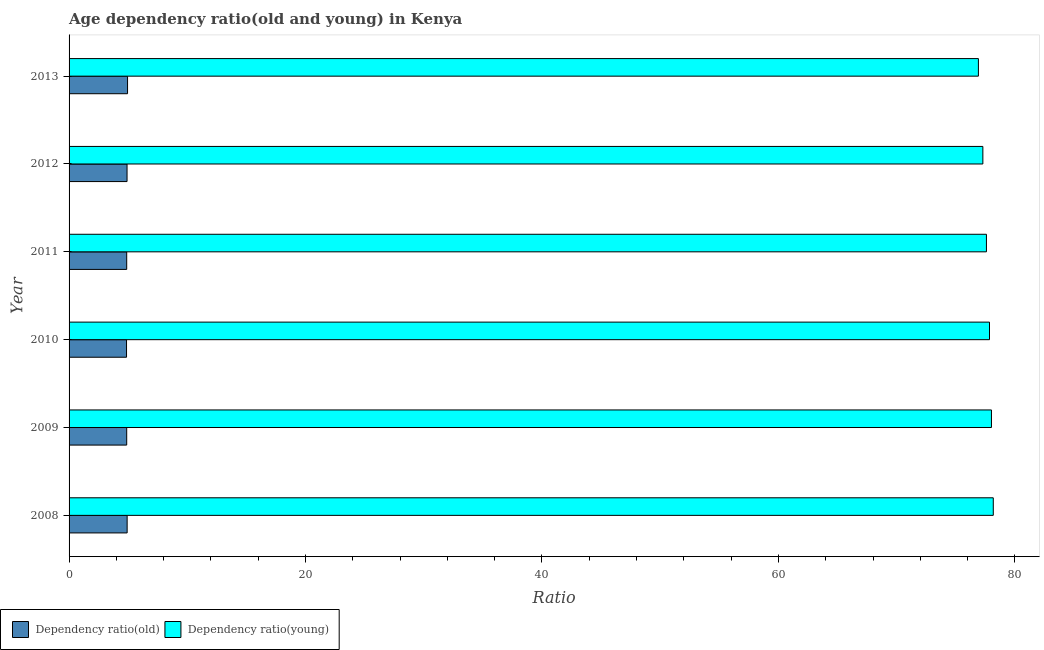How many different coloured bars are there?
Provide a succinct answer. 2. Are the number of bars on each tick of the Y-axis equal?
Offer a very short reply. Yes. In how many cases, is the number of bars for a given year not equal to the number of legend labels?
Provide a succinct answer. 0. What is the age dependency ratio(young) in 2009?
Give a very brief answer. 78.02. Across all years, what is the maximum age dependency ratio(old)?
Offer a very short reply. 4.95. Across all years, what is the minimum age dependency ratio(young)?
Provide a succinct answer. 76.92. In which year was the age dependency ratio(old) maximum?
Offer a terse response. 2013. In which year was the age dependency ratio(young) minimum?
Keep it short and to the point. 2013. What is the total age dependency ratio(old) in the graph?
Offer a terse response. 29.37. What is the difference between the age dependency ratio(old) in 2012 and that in 2013?
Your answer should be compact. -0.04. What is the difference between the age dependency ratio(old) in 2013 and the age dependency ratio(young) in 2011?
Provide a short and direct response. -72.65. What is the average age dependency ratio(old) per year?
Ensure brevity in your answer.  4.89. In the year 2009, what is the difference between the age dependency ratio(old) and age dependency ratio(young)?
Make the answer very short. -73.14. What is the difference between the highest and the second highest age dependency ratio(young)?
Your answer should be very brief. 0.15. What is the difference between the highest and the lowest age dependency ratio(young)?
Provide a short and direct response. 1.26. In how many years, is the age dependency ratio(young) greater than the average age dependency ratio(young) taken over all years?
Give a very brief answer. 3. What does the 2nd bar from the top in 2010 represents?
Provide a succinct answer. Dependency ratio(old). What does the 1st bar from the bottom in 2012 represents?
Provide a succinct answer. Dependency ratio(old). How many bars are there?
Offer a terse response. 12. What is the difference between two consecutive major ticks on the X-axis?
Offer a very short reply. 20. Does the graph contain any zero values?
Keep it short and to the point. No. Where does the legend appear in the graph?
Your answer should be very brief. Bottom left. What is the title of the graph?
Your answer should be compact. Age dependency ratio(old and young) in Kenya. Does "Time to import" appear as one of the legend labels in the graph?
Make the answer very short. No. What is the label or title of the X-axis?
Give a very brief answer. Ratio. What is the label or title of the Y-axis?
Keep it short and to the point. Year. What is the Ratio of Dependency ratio(old) in 2008?
Offer a terse response. 4.91. What is the Ratio in Dependency ratio(young) in 2008?
Provide a succinct answer. 78.17. What is the Ratio in Dependency ratio(old) in 2009?
Offer a very short reply. 4.87. What is the Ratio of Dependency ratio(young) in 2009?
Make the answer very short. 78.02. What is the Ratio in Dependency ratio(old) in 2010?
Keep it short and to the point. 4.86. What is the Ratio of Dependency ratio(young) in 2010?
Your answer should be compact. 77.85. What is the Ratio in Dependency ratio(old) in 2011?
Your response must be concise. 4.87. What is the Ratio in Dependency ratio(young) in 2011?
Provide a succinct answer. 77.6. What is the Ratio in Dependency ratio(old) in 2012?
Provide a short and direct response. 4.9. What is the Ratio in Dependency ratio(young) in 2012?
Offer a very short reply. 77.29. What is the Ratio in Dependency ratio(old) in 2013?
Your answer should be very brief. 4.95. What is the Ratio in Dependency ratio(young) in 2013?
Keep it short and to the point. 76.92. Across all years, what is the maximum Ratio of Dependency ratio(old)?
Provide a succinct answer. 4.95. Across all years, what is the maximum Ratio of Dependency ratio(young)?
Your answer should be compact. 78.17. Across all years, what is the minimum Ratio in Dependency ratio(old)?
Keep it short and to the point. 4.86. Across all years, what is the minimum Ratio of Dependency ratio(young)?
Keep it short and to the point. 76.92. What is the total Ratio of Dependency ratio(old) in the graph?
Provide a short and direct response. 29.37. What is the total Ratio in Dependency ratio(young) in the graph?
Your response must be concise. 465.85. What is the difference between the Ratio of Dependency ratio(old) in 2008 and that in 2009?
Give a very brief answer. 0.04. What is the difference between the Ratio of Dependency ratio(young) in 2008 and that in 2009?
Your answer should be compact. 0.16. What is the difference between the Ratio of Dependency ratio(old) in 2008 and that in 2010?
Your answer should be compact. 0.05. What is the difference between the Ratio of Dependency ratio(young) in 2008 and that in 2010?
Provide a short and direct response. 0.32. What is the difference between the Ratio of Dependency ratio(old) in 2008 and that in 2011?
Offer a terse response. 0.04. What is the difference between the Ratio in Dependency ratio(young) in 2008 and that in 2011?
Your answer should be very brief. 0.58. What is the difference between the Ratio of Dependency ratio(old) in 2008 and that in 2012?
Provide a short and direct response. 0.01. What is the difference between the Ratio in Dependency ratio(young) in 2008 and that in 2012?
Give a very brief answer. 0.88. What is the difference between the Ratio in Dependency ratio(old) in 2008 and that in 2013?
Your response must be concise. -0.03. What is the difference between the Ratio of Dependency ratio(young) in 2008 and that in 2013?
Offer a terse response. 1.26. What is the difference between the Ratio in Dependency ratio(old) in 2009 and that in 2010?
Provide a succinct answer. 0.01. What is the difference between the Ratio of Dependency ratio(young) in 2009 and that in 2010?
Offer a very short reply. 0.17. What is the difference between the Ratio of Dependency ratio(old) in 2009 and that in 2011?
Your answer should be very brief. -0. What is the difference between the Ratio of Dependency ratio(young) in 2009 and that in 2011?
Ensure brevity in your answer.  0.42. What is the difference between the Ratio in Dependency ratio(old) in 2009 and that in 2012?
Provide a succinct answer. -0.03. What is the difference between the Ratio in Dependency ratio(young) in 2009 and that in 2012?
Give a very brief answer. 0.73. What is the difference between the Ratio of Dependency ratio(old) in 2009 and that in 2013?
Your answer should be compact. -0.07. What is the difference between the Ratio of Dependency ratio(young) in 2009 and that in 2013?
Offer a terse response. 1.1. What is the difference between the Ratio in Dependency ratio(old) in 2010 and that in 2011?
Provide a succinct answer. -0.01. What is the difference between the Ratio in Dependency ratio(young) in 2010 and that in 2011?
Your answer should be compact. 0.26. What is the difference between the Ratio of Dependency ratio(old) in 2010 and that in 2012?
Your answer should be very brief. -0.04. What is the difference between the Ratio in Dependency ratio(young) in 2010 and that in 2012?
Your response must be concise. 0.56. What is the difference between the Ratio of Dependency ratio(old) in 2010 and that in 2013?
Make the answer very short. -0.09. What is the difference between the Ratio of Dependency ratio(young) in 2010 and that in 2013?
Keep it short and to the point. 0.94. What is the difference between the Ratio in Dependency ratio(old) in 2011 and that in 2012?
Make the answer very short. -0.03. What is the difference between the Ratio in Dependency ratio(young) in 2011 and that in 2012?
Offer a very short reply. 0.3. What is the difference between the Ratio in Dependency ratio(old) in 2011 and that in 2013?
Provide a short and direct response. -0.07. What is the difference between the Ratio of Dependency ratio(young) in 2011 and that in 2013?
Offer a very short reply. 0.68. What is the difference between the Ratio of Dependency ratio(old) in 2012 and that in 2013?
Provide a short and direct response. -0.04. What is the difference between the Ratio in Dependency ratio(young) in 2012 and that in 2013?
Give a very brief answer. 0.38. What is the difference between the Ratio of Dependency ratio(old) in 2008 and the Ratio of Dependency ratio(young) in 2009?
Your answer should be compact. -73.11. What is the difference between the Ratio in Dependency ratio(old) in 2008 and the Ratio in Dependency ratio(young) in 2010?
Your answer should be very brief. -72.94. What is the difference between the Ratio of Dependency ratio(old) in 2008 and the Ratio of Dependency ratio(young) in 2011?
Your answer should be very brief. -72.68. What is the difference between the Ratio in Dependency ratio(old) in 2008 and the Ratio in Dependency ratio(young) in 2012?
Your answer should be compact. -72.38. What is the difference between the Ratio of Dependency ratio(old) in 2008 and the Ratio of Dependency ratio(young) in 2013?
Your response must be concise. -72.01. What is the difference between the Ratio in Dependency ratio(old) in 2009 and the Ratio in Dependency ratio(young) in 2010?
Your answer should be compact. -72.98. What is the difference between the Ratio in Dependency ratio(old) in 2009 and the Ratio in Dependency ratio(young) in 2011?
Your answer should be compact. -72.72. What is the difference between the Ratio of Dependency ratio(old) in 2009 and the Ratio of Dependency ratio(young) in 2012?
Provide a succinct answer. -72.42. What is the difference between the Ratio in Dependency ratio(old) in 2009 and the Ratio in Dependency ratio(young) in 2013?
Make the answer very short. -72.04. What is the difference between the Ratio of Dependency ratio(old) in 2010 and the Ratio of Dependency ratio(young) in 2011?
Offer a very short reply. -72.74. What is the difference between the Ratio of Dependency ratio(old) in 2010 and the Ratio of Dependency ratio(young) in 2012?
Make the answer very short. -72.43. What is the difference between the Ratio of Dependency ratio(old) in 2010 and the Ratio of Dependency ratio(young) in 2013?
Make the answer very short. -72.06. What is the difference between the Ratio of Dependency ratio(old) in 2011 and the Ratio of Dependency ratio(young) in 2012?
Ensure brevity in your answer.  -72.42. What is the difference between the Ratio of Dependency ratio(old) in 2011 and the Ratio of Dependency ratio(young) in 2013?
Offer a terse response. -72.04. What is the difference between the Ratio of Dependency ratio(old) in 2012 and the Ratio of Dependency ratio(young) in 2013?
Make the answer very short. -72.01. What is the average Ratio in Dependency ratio(old) per year?
Your answer should be compact. 4.9. What is the average Ratio of Dependency ratio(young) per year?
Provide a succinct answer. 77.64. In the year 2008, what is the difference between the Ratio of Dependency ratio(old) and Ratio of Dependency ratio(young)?
Offer a terse response. -73.26. In the year 2009, what is the difference between the Ratio of Dependency ratio(old) and Ratio of Dependency ratio(young)?
Ensure brevity in your answer.  -73.15. In the year 2010, what is the difference between the Ratio in Dependency ratio(old) and Ratio in Dependency ratio(young)?
Your answer should be very brief. -72.99. In the year 2011, what is the difference between the Ratio of Dependency ratio(old) and Ratio of Dependency ratio(young)?
Your answer should be very brief. -72.72. In the year 2012, what is the difference between the Ratio of Dependency ratio(old) and Ratio of Dependency ratio(young)?
Your answer should be compact. -72.39. In the year 2013, what is the difference between the Ratio in Dependency ratio(old) and Ratio in Dependency ratio(young)?
Give a very brief answer. -71.97. What is the ratio of the Ratio of Dependency ratio(old) in 2008 to that in 2009?
Give a very brief answer. 1.01. What is the ratio of the Ratio of Dependency ratio(old) in 2008 to that in 2010?
Offer a very short reply. 1.01. What is the ratio of the Ratio of Dependency ratio(old) in 2008 to that in 2011?
Provide a short and direct response. 1.01. What is the ratio of the Ratio of Dependency ratio(young) in 2008 to that in 2011?
Your response must be concise. 1.01. What is the ratio of the Ratio of Dependency ratio(young) in 2008 to that in 2012?
Provide a succinct answer. 1.01. What is the ratio of the Ratio of Dependency ratio(young) in 2008 to that in 2013?
Ensure brevity in your answer.  1.02. What is the ratio of the Ratio of Dependency ratio(old) in 2009 to that in 2010?
Offer a terse response. 1. What is the ratio of the Ratio of Dependency ratio(young) in 2009 to that in 2010?
Make the answer very short. 1. What is the ratio of the Ratio in Dependency ratio(old) in 2009 to that in 2011?
Ensure brevity in your answer.  1. What is the ratio of the Ratio of Dependency ratio(old) in 2009 to that in 2012?
Keep it short and to the point. 0.99. What is the ratio of the Ratio in Dependency ratio(young) in 2009 to that in 2012?
Your answer should be compact. 1.01. What is the ratio of the Ratio in Dependency ratio(old) in 2009 to that in 2013?
Offer a terse response. 0.99. What is the ratio of the Ratio of Dependency ratio(young) in 2009 to that in 2013?
Ensure brevity in your answer.  1.01. What is the ratio of the Ratio of Dependency ratio(young) in 2010 to that in 2011?
Provide a succinct answer. 1. What is the ratio of the Ratio in Dependency ratio(old) in 2010 to that in 2012?
Make the answer very short. 0.99. What is the ratio of the Ratio in Dependency ratio(young) in 2010 to that in 2012?
Your answer should be compact. 1.01. What is the ratio of the Ratio in Dependency ratio(old) in 2010 to that in 2013?
Offer a terse response. 0.98. What is the ratio of the Ratio of Dependency ratio(young) in 2010 to that in 2013?
Offer a very short reply. 1.01. What is the ratio of the Ratio of Dependency ratio(old) in 2011 to that in 2013?
Offer a very short reply. 0.99. What is the ratio of the Ratio of Dependency ratio(young) in 2011 to that in 2013?
Offer a terse response. 1.01. What is the ratio of the Ratio of Dependency ratio(young) in 2012 to that in 2013?
Ensure brevity in your answer.  1. What is the difference between the highest and the second highest Ratio in Dependency ratio(old)?
Your answer should be compact. 0.03. What is the difference between the highest and the second highest Ratio of Dependency ratio(young)?
Make the answer very short. 0.16. What is the difference between the highest and the lowest Ratio of Dependency ratio(old)?
Offer a terse response. 0.09. What is the difference between the highest and the lowest Ratio in Dependency ratio(young)?
Provide a succinct answer. 1.26. 